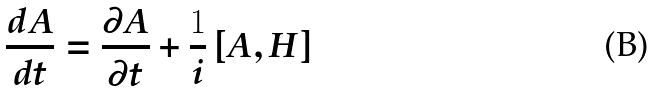Convert formula to latex. <formula><loc_0><loc_0><loc_500><loc_500>\frac { d A } { d t } = \frac { \partial A } { \partial t } + \frac { 1 } { i } \left [ A , H \right ] \,</formula> 